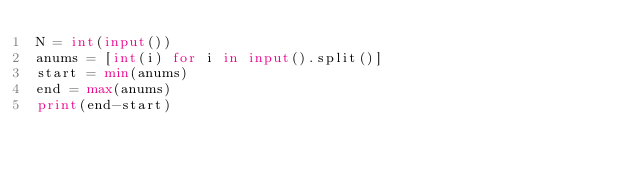Convert code to text. <code><loc_0><loc_0><loc_500><loc_500><_Python_>N = int(input())
anums = [int(i) for i in input().split()]
start = min(anums)
end = max(anums)
print(end-start)</code> 